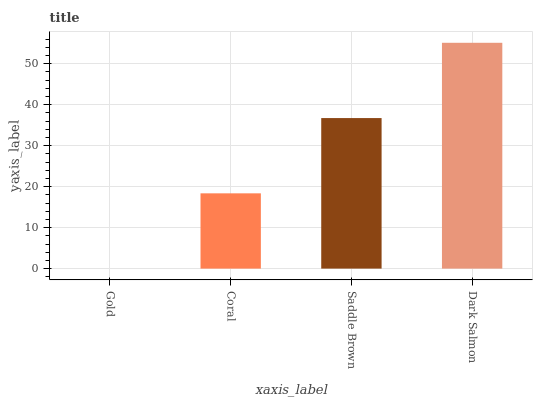Is Gold the minimum?
Answer yes or no. Yes. Is Dark Salmon the maximum?
Answer yes or no. Yes. Is Coral the minimum?
Answer yes or no. No. Is Coral the maximum?
Answer yes or no. No. Is Coral greater than Gold?
Answer yes or no. Yes. Is Gold less than Coral?
Answer yes or no. Yes. Is Gold greater than Coral?
Answer yes or no. No. Is Coral less than Gold?
Answer yes or no. No. Is Saddle Brown the high median?
Answer yes or no. Yes. Is Coral the low median?
Answer yes or no. Yes. Is Coral the high median?
Answer yes or no. No. Is Dark Salmon the low median?
Answer yes or no. No. 